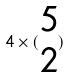Convert formula to latex. <formula><loc_0><loc_0><loc_500><loc_500>4 \times ( \begin{matrix} 5 \\ 2 \end{matrix} )</formula> 